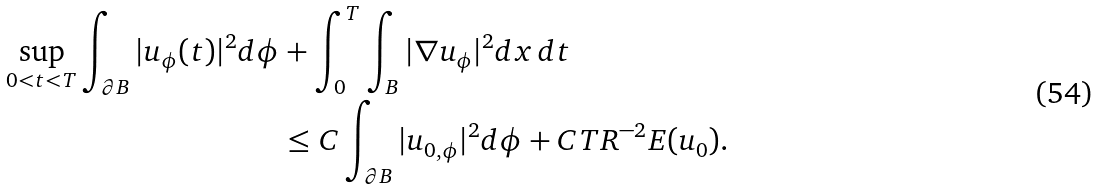<formula> <loc_0><loc_0><loc_500><loc_500>\sup _ { 0 < t < T } \int _ { \partial B } | u _ { \phi } ( t ) | ^ { 2 } d \phi & + \int _ { 0 } ^ { T } \int _ { B } | \nabla u _ { \phi } | ^ { 2 } d x \, d t \\ & \leq C \int _ { \partial B } | u _ { 0 , \phi } | ^ { 2 } d \phi + C T R ^ { - 2 } E ( u _ { 0 } ) .</formula> 